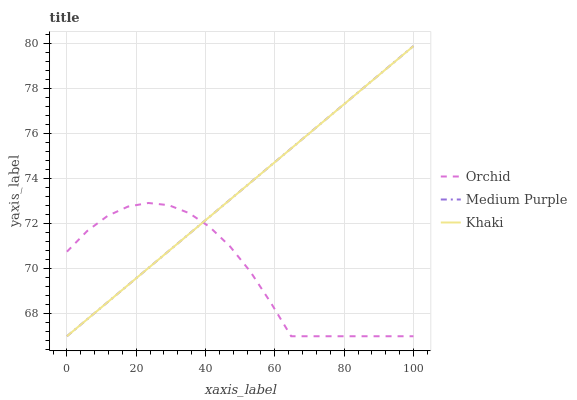Does Orchid have the minimum area under the curve?
Answer yes or no. Yes. Does Medium Purple have the maximum area under the curve?
Answer yes or no. Yes. Does Khaki have the minimum area under the curve?
Answer yes or no. No. Does Khaki have the maximum area under the curve?
Answer yes or no. No. Is Medium Purple the smoothest?
Answer yes or no. Yes. Is Orchid the roughest?
Answer yes or no. Yes. Is Khaki the smoothest?
Answer yes or no. No. Is Khaki the roughest?
Answer yes or no. No. Does Medium Purple have the lowest value?
Answer yes or no. Yes. Does Medium Purple have the highest value?
Answer yes or no. Yes. Does Khaki have the highest value?
Answer yes or no. No. Does Medium Purple intersect Orchid?
Answer yes or no. Yes. Is Medium Purple less than Orchid?
Answer yes or no. No. Is Medium Purple greater than Orchid?
Answer yes or no. No. 